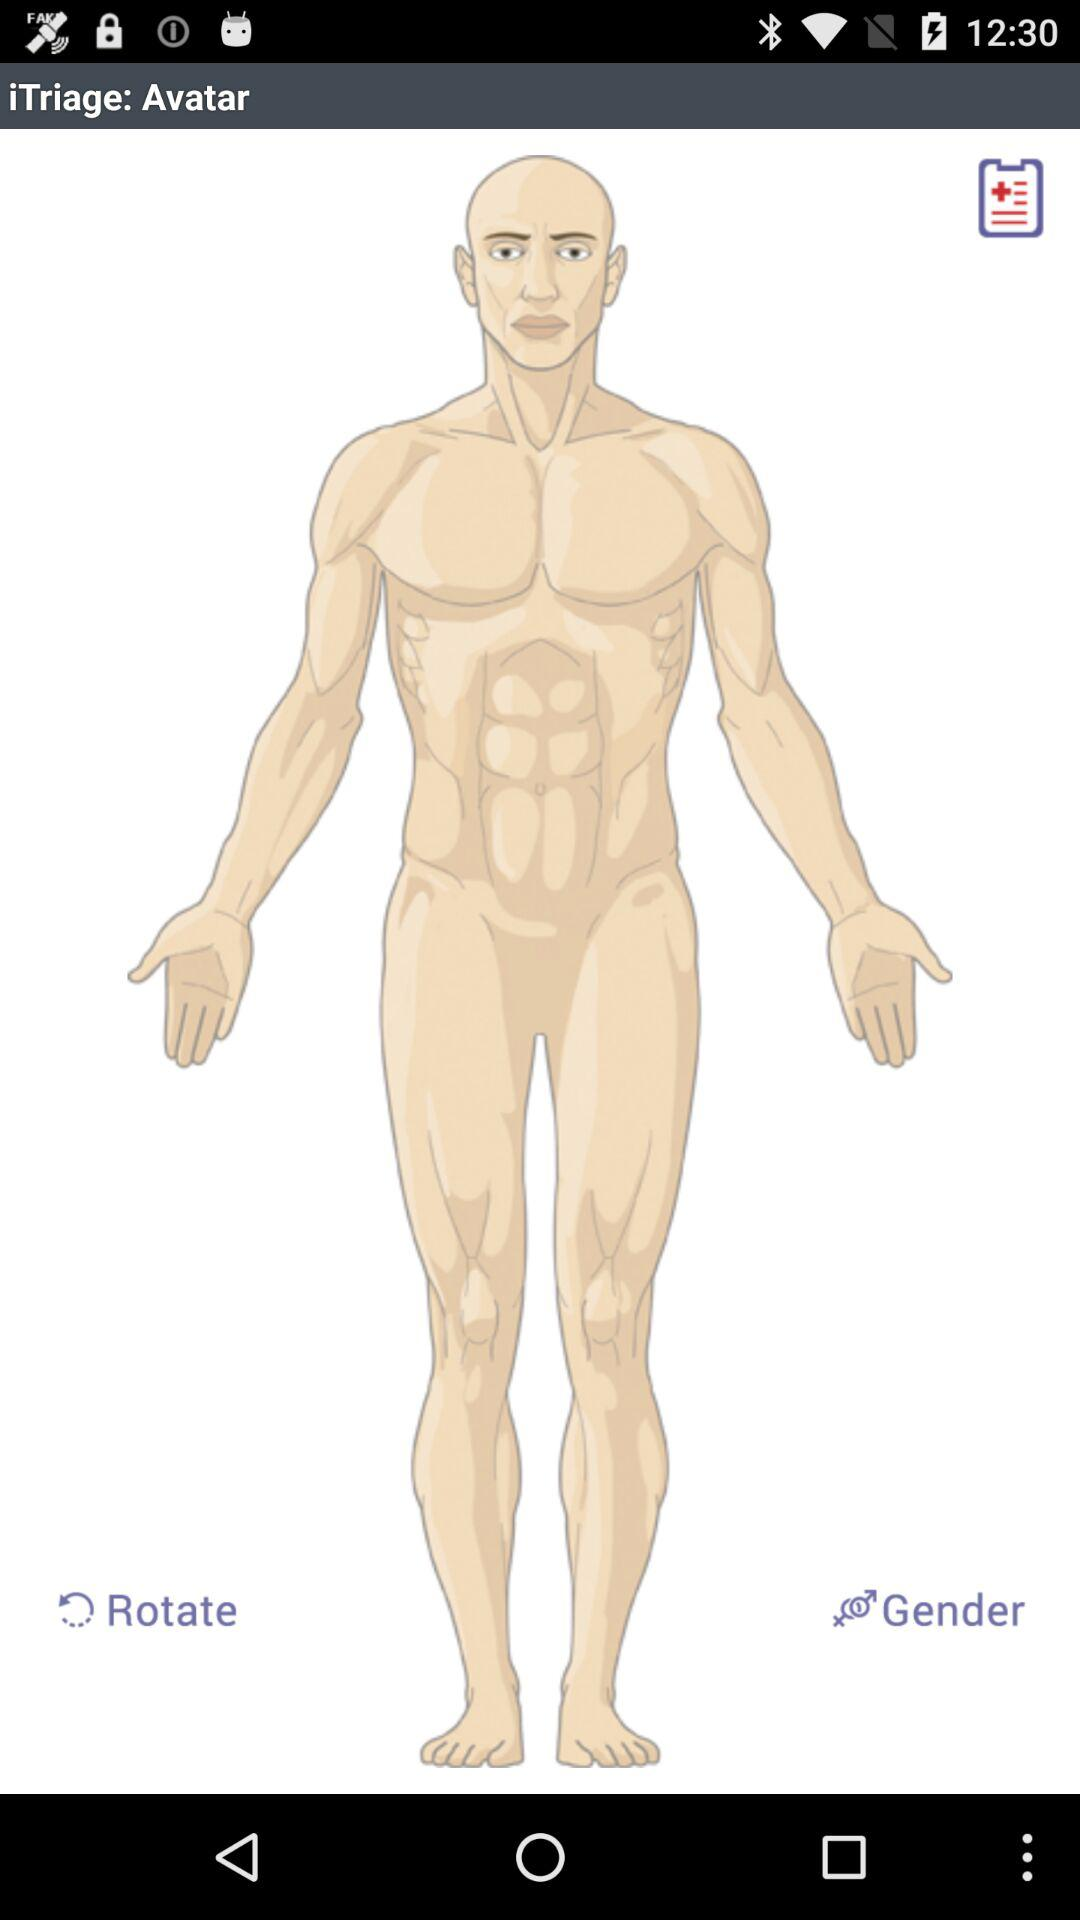What is the name of the application? The name of the application is "iTriage". 